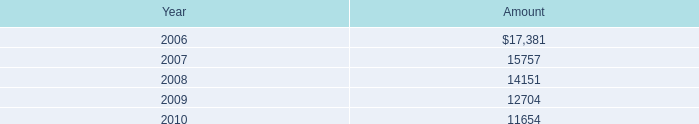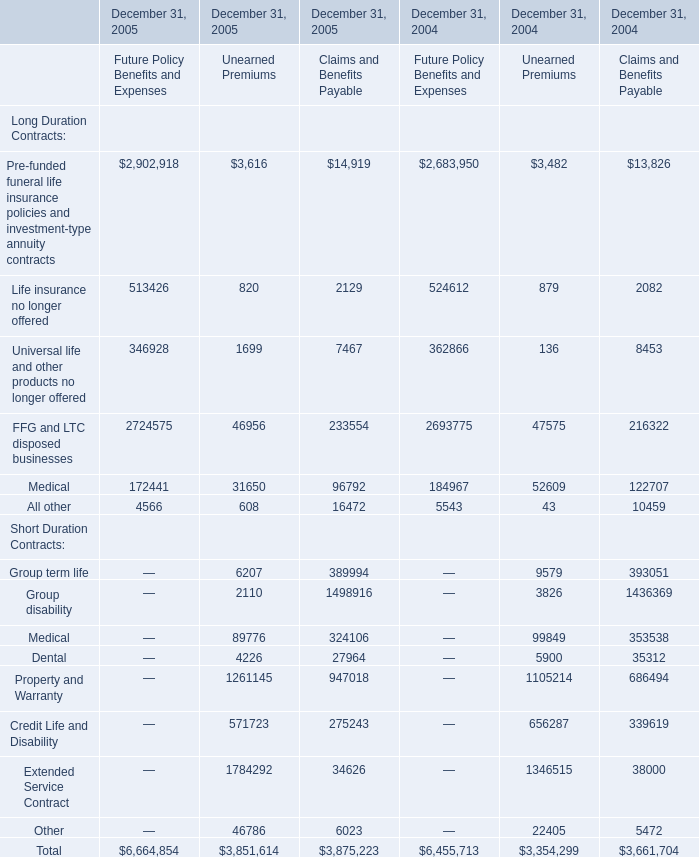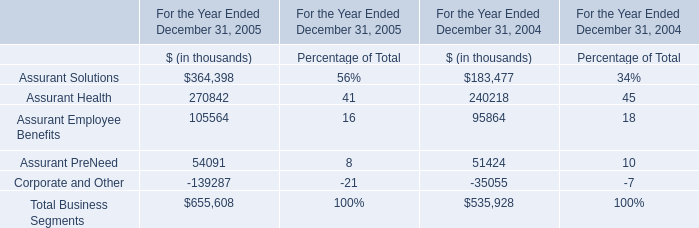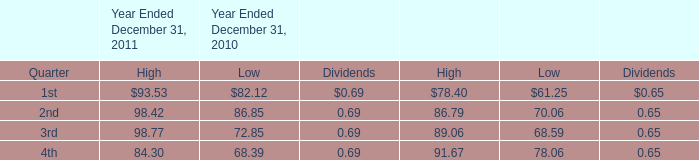Which year is the Unearned Premiums for Total on December 31 the most? 
Answer: 2005. 